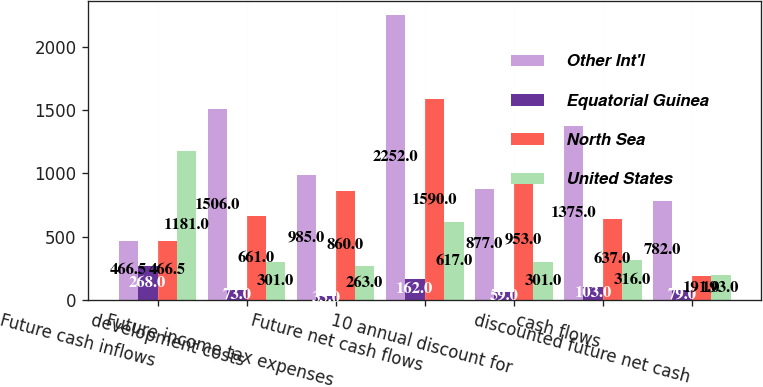<chart> <loc_0><loc_0><loc_500><loc_500><stacked_bar_chart><ecel><fcel>Future cash inflows<fcel>development costs<fcel>Future income tax expenses<fcel>Future net cash flows<fcel>10 annual discount for<fcel>cash flows<fcel>discounted future net cash<nl><fcel>Other Int'l<fcel>466.5<fcel>1506<fcel>985<fcel>2252<fcel>877<fcel>1375<fcel>782<nl><fcel>Equatorial Guinea<fcel>268<fcel>73<fcel>33<fcel>162<fcel>59<fcel>103<fcel>79<nl><fcel>North Sea<fcel>466.5<fcel>661<fcel>860<fcel>1590<fcel>953<fcel>637<fcel>191<nl><fcel>United States<fcel>1181<fcel>301<fcel>263<fcel>617<fcel>301<fcel>316<fcel>193<nl></chart> 